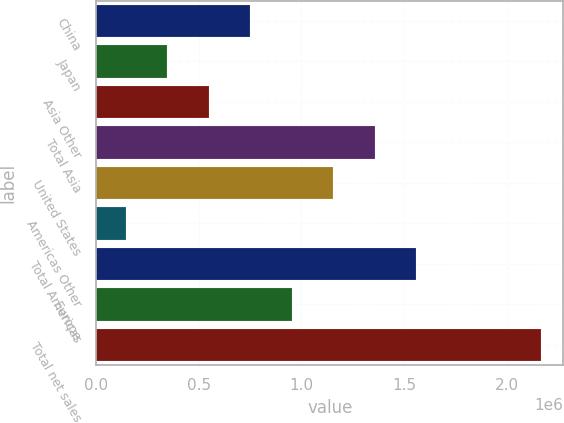Convert chart to OTSL. <chart><loc_0><loc_0><loc_500><loc_500><bar_chart><fcel>China<fcel>Japan<fcel>Asia Other<fcel>Total Asia<fcel>United States<fcel>Americas Other<fcel>Total Americas<fcel>Europe<fcel>Total net sales<nl><fcel>749558<fcel>344454<fcel>547006<fcel>1.35721e+06<fcel>1.15466e+06<fcel>141902<fcel>1.55977e+06<fcel>952110<fcel>2.16742e+06<nl></chart> 